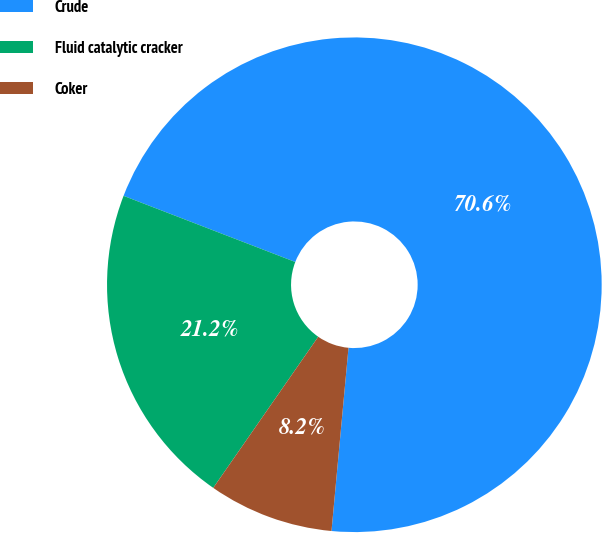<chart> <loc_0><loc_0><loc_500><loc_500><pie_chart><fcel>Crude<fcel>Fluid catalytic cracker<fcel>Coker<nl><fcel>70.62%<fcel>21.19%<fcel>8.19%<nl></chart> 